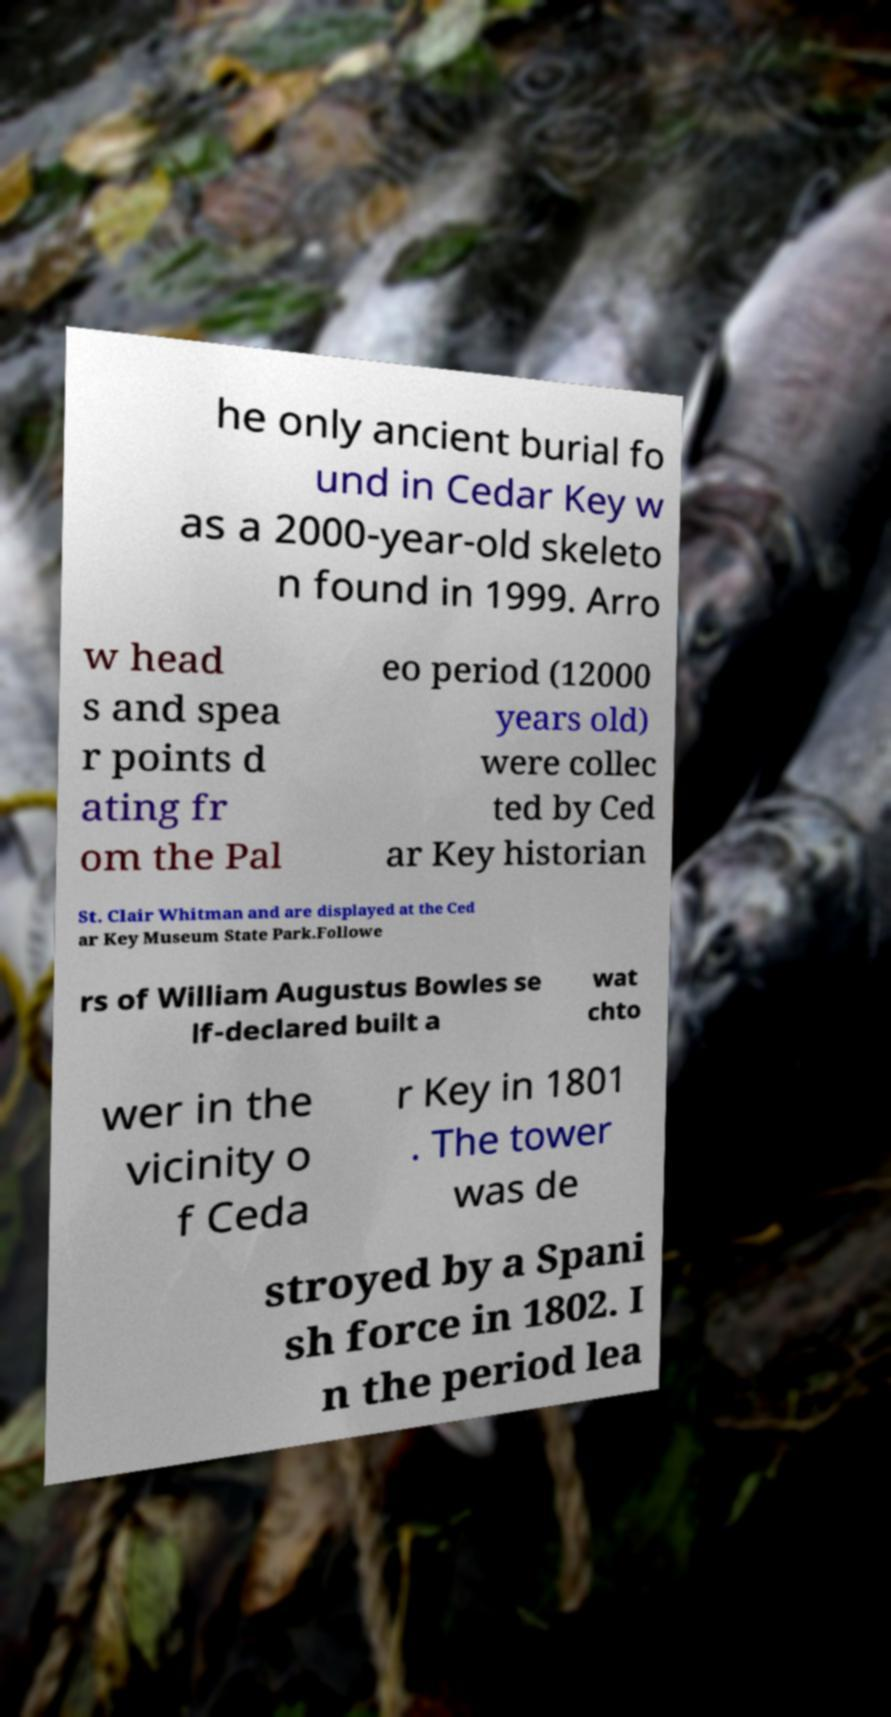I need the written content from this picture converted into text. Can you do that? he only ancient burial fo und in Cedar Key w as a 2000-year-old skeleto n found in 1999. Arro w head s and spea r points d ating fr om the Pal eo period (12000 years old) were collec ted by Ced ar Key historian St. Clair Whitman and are displayed at the Ced ar Key Museum State Park.Followe rs of William Augustus Bowles se lf-declared built a wat chto wer in the vicinity o f Ceda r Key in 1801 . The tower was de stroyed by a Spani sh force in 1802. I n the period lea 